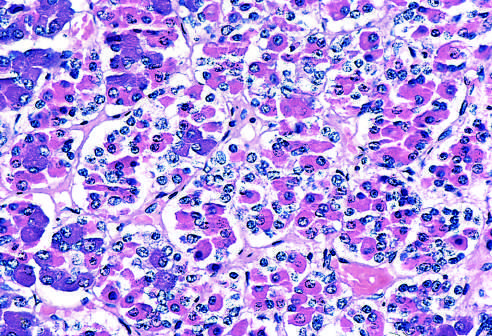s the gland populated by several distinct cell types that express different peptide hormones?
Answer the question using a single word or phrase. Yes 